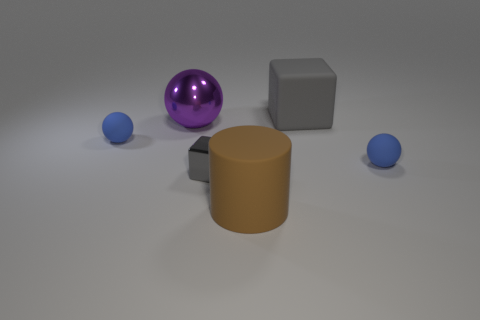What material is the large thing that is the same color as the metallic cube? The large object that shares the same grey color as the metallic cube appears to be a cylinder made of plastic or a matte finished metal, which contrasts with the shinier surface of the cube. 